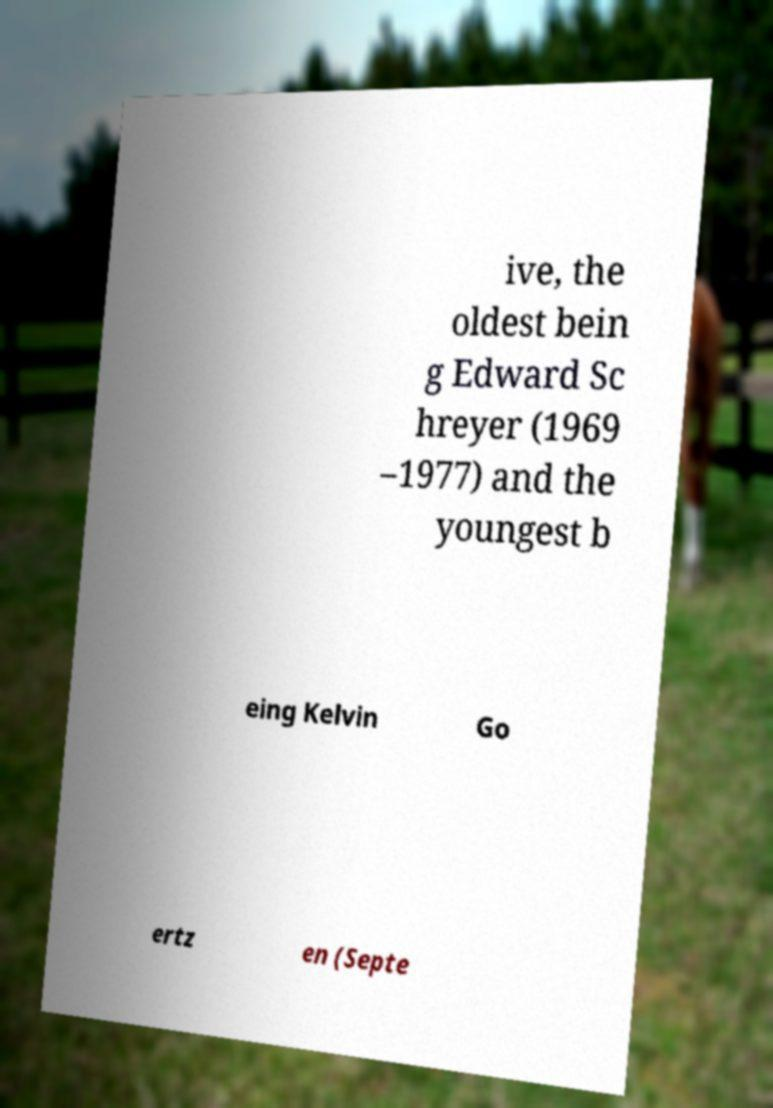What messages or text are displayed in this image? I need them in a readable, typed format. ive, the oldest bein g Edward Sc hreyer (1969 –1977) and the youngest b eing Kelvin Go ertz en (Septe 